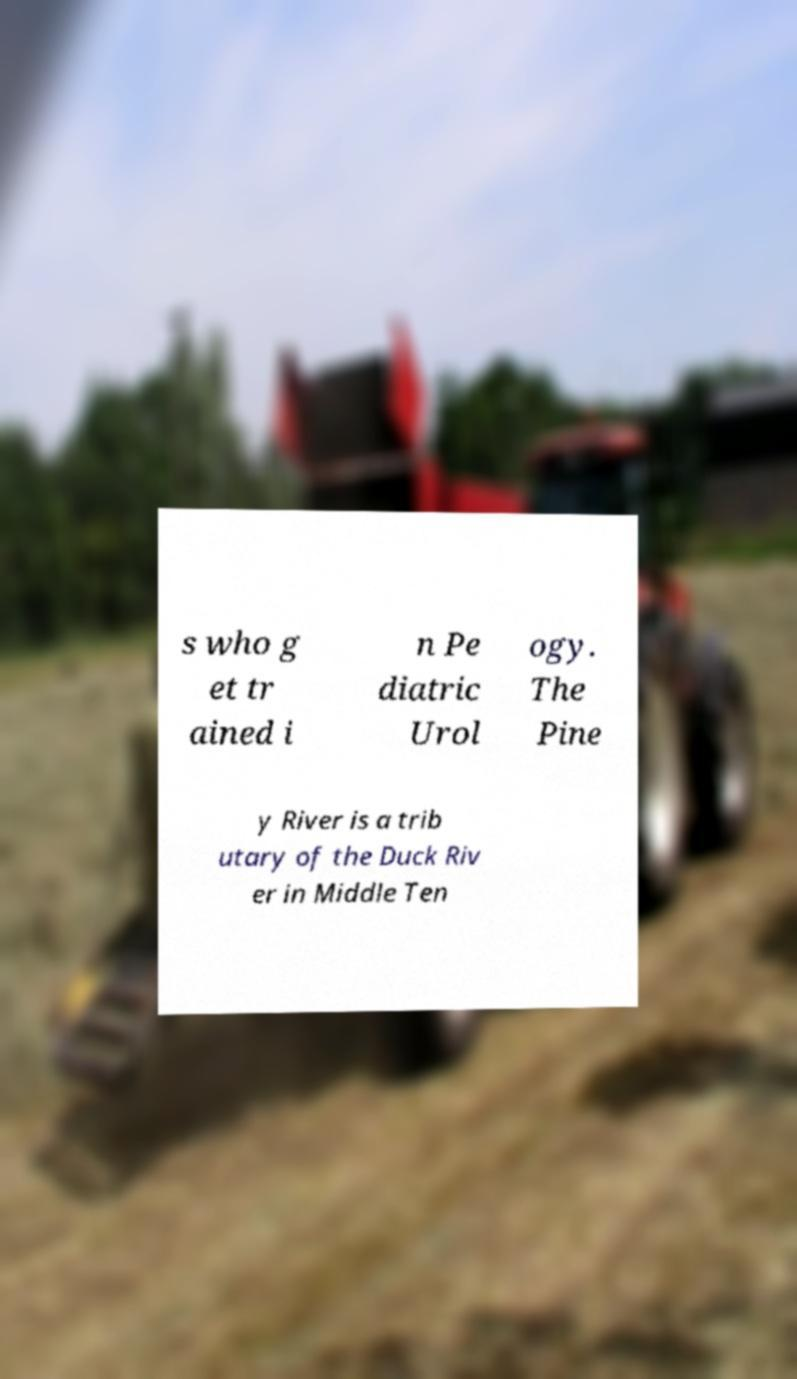Could you assist in decoding the text presented in this image and type it out clearly? s who g et tr ained i n Pe diatric Urol ogy. The Pine y River is a trib utary of the Duck Riv er in Middle Ten 